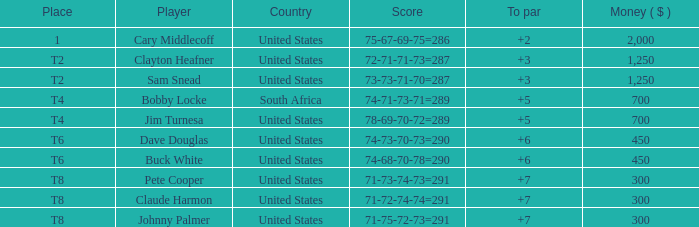What nation does player sam snead, with a to par of under 5, belong to? United States. 